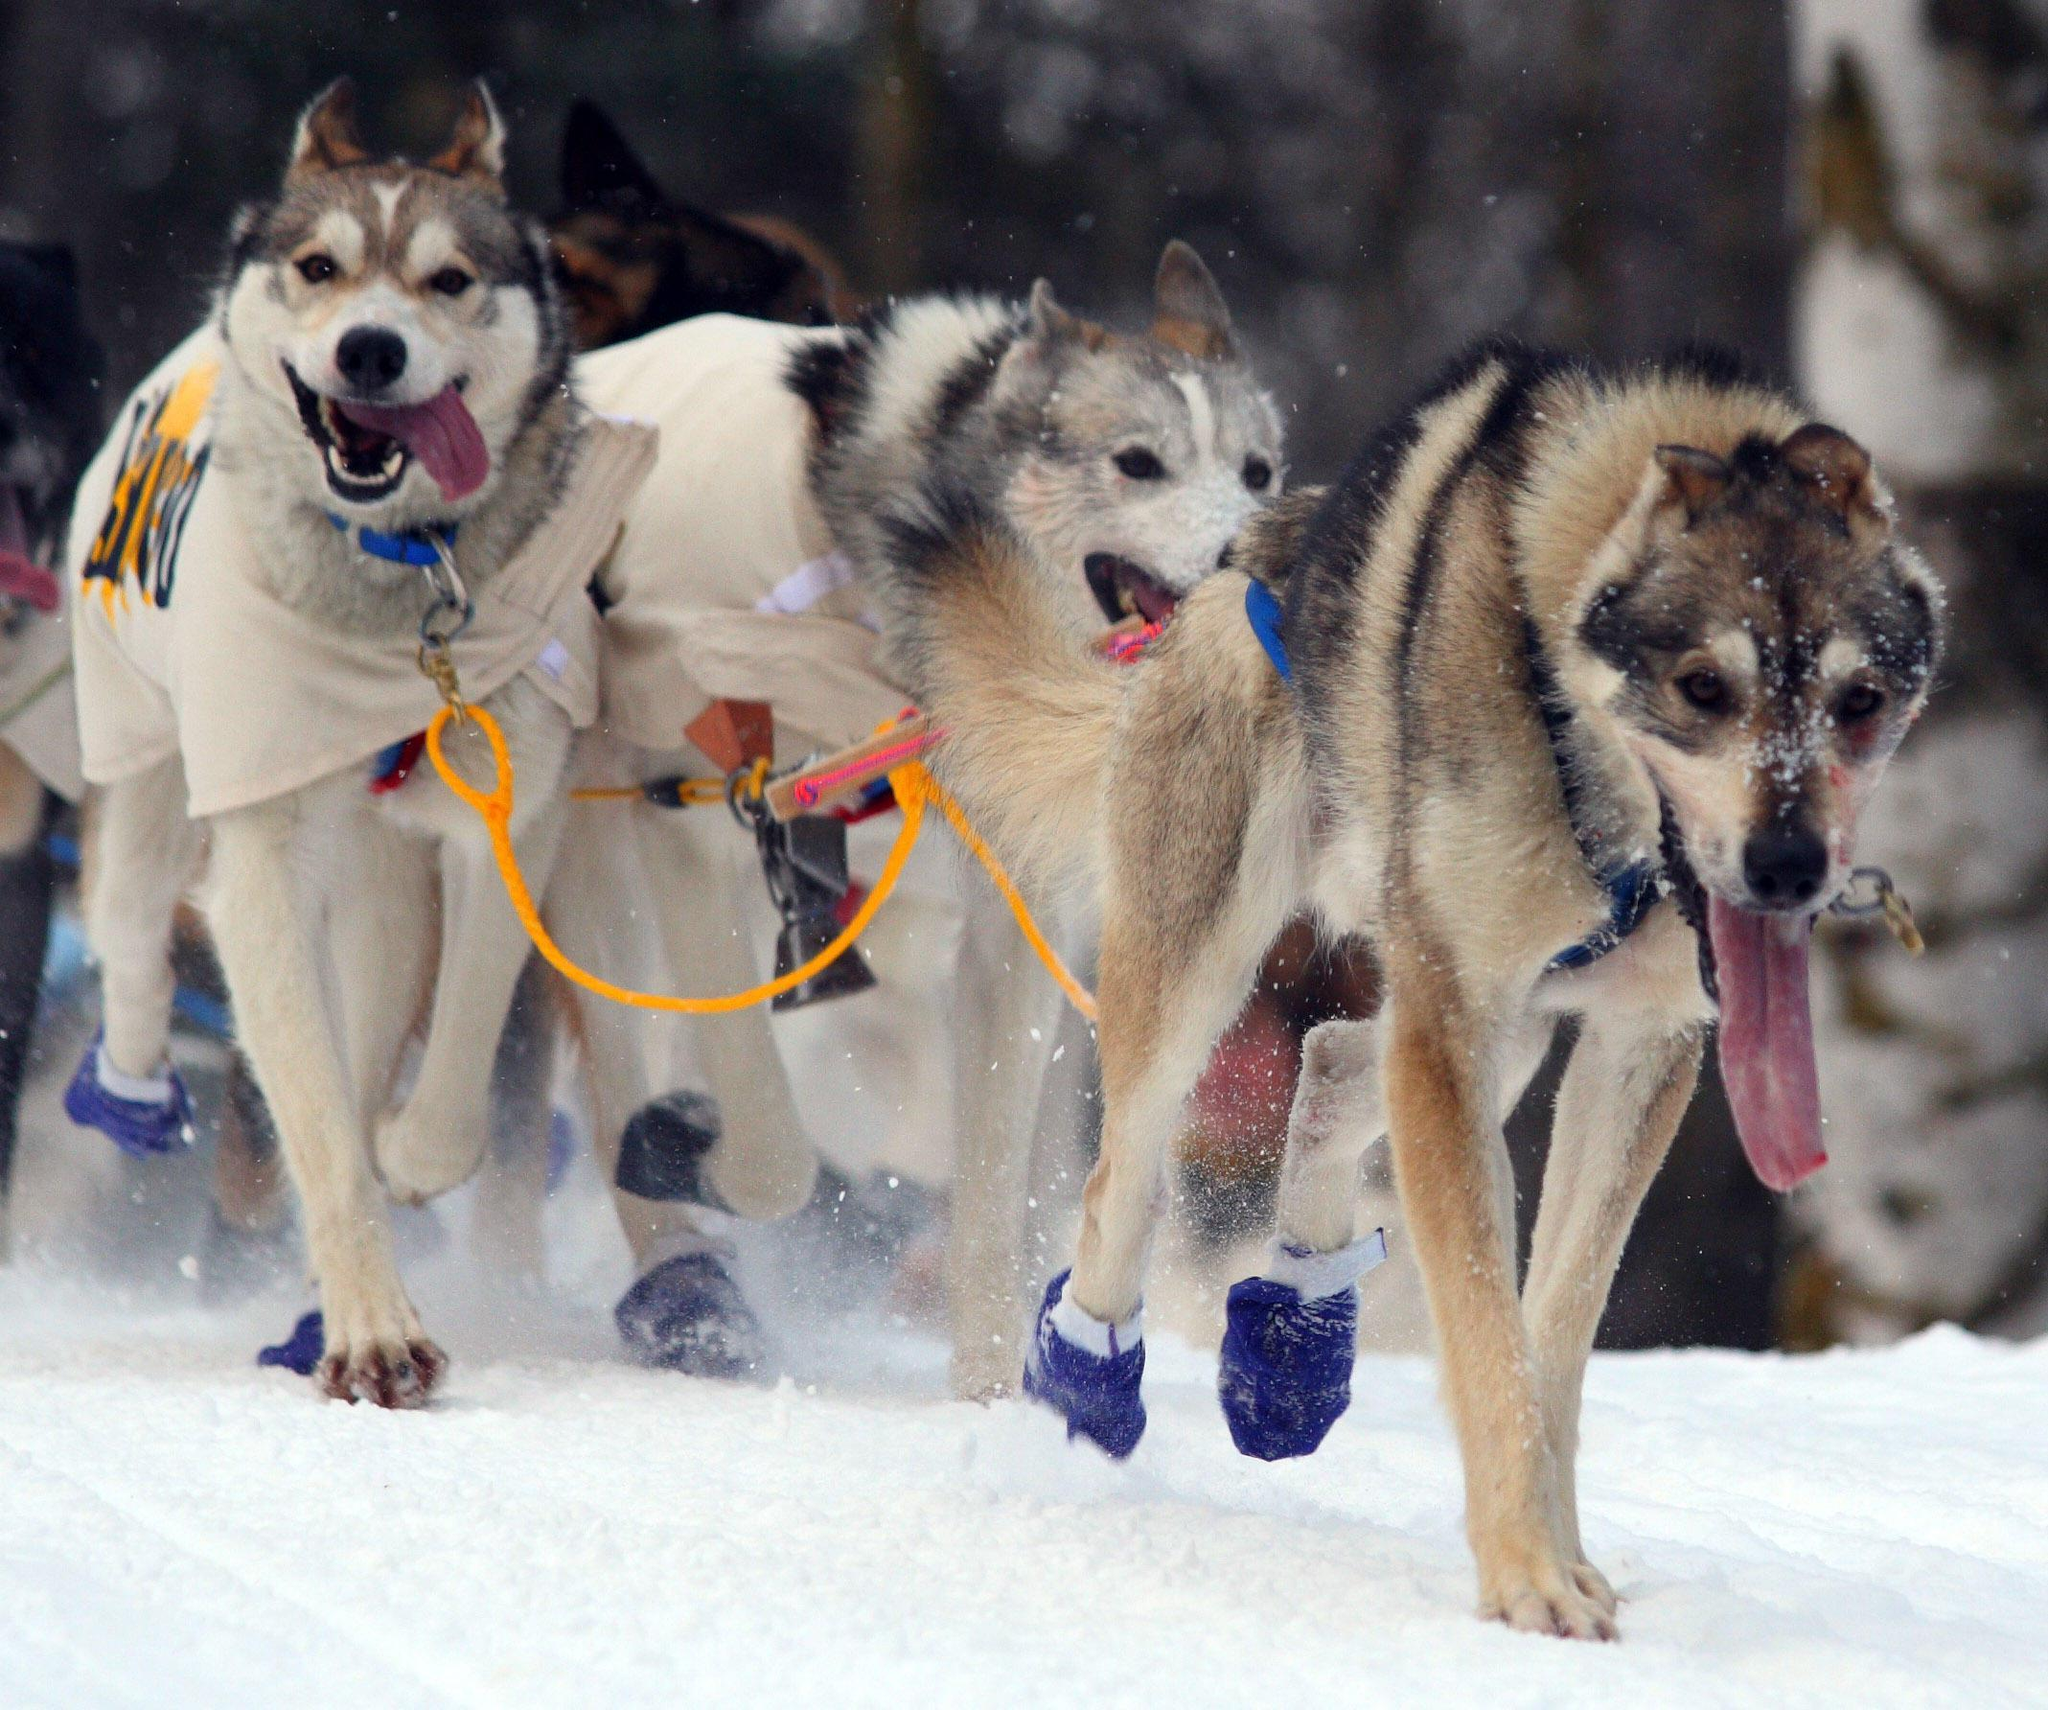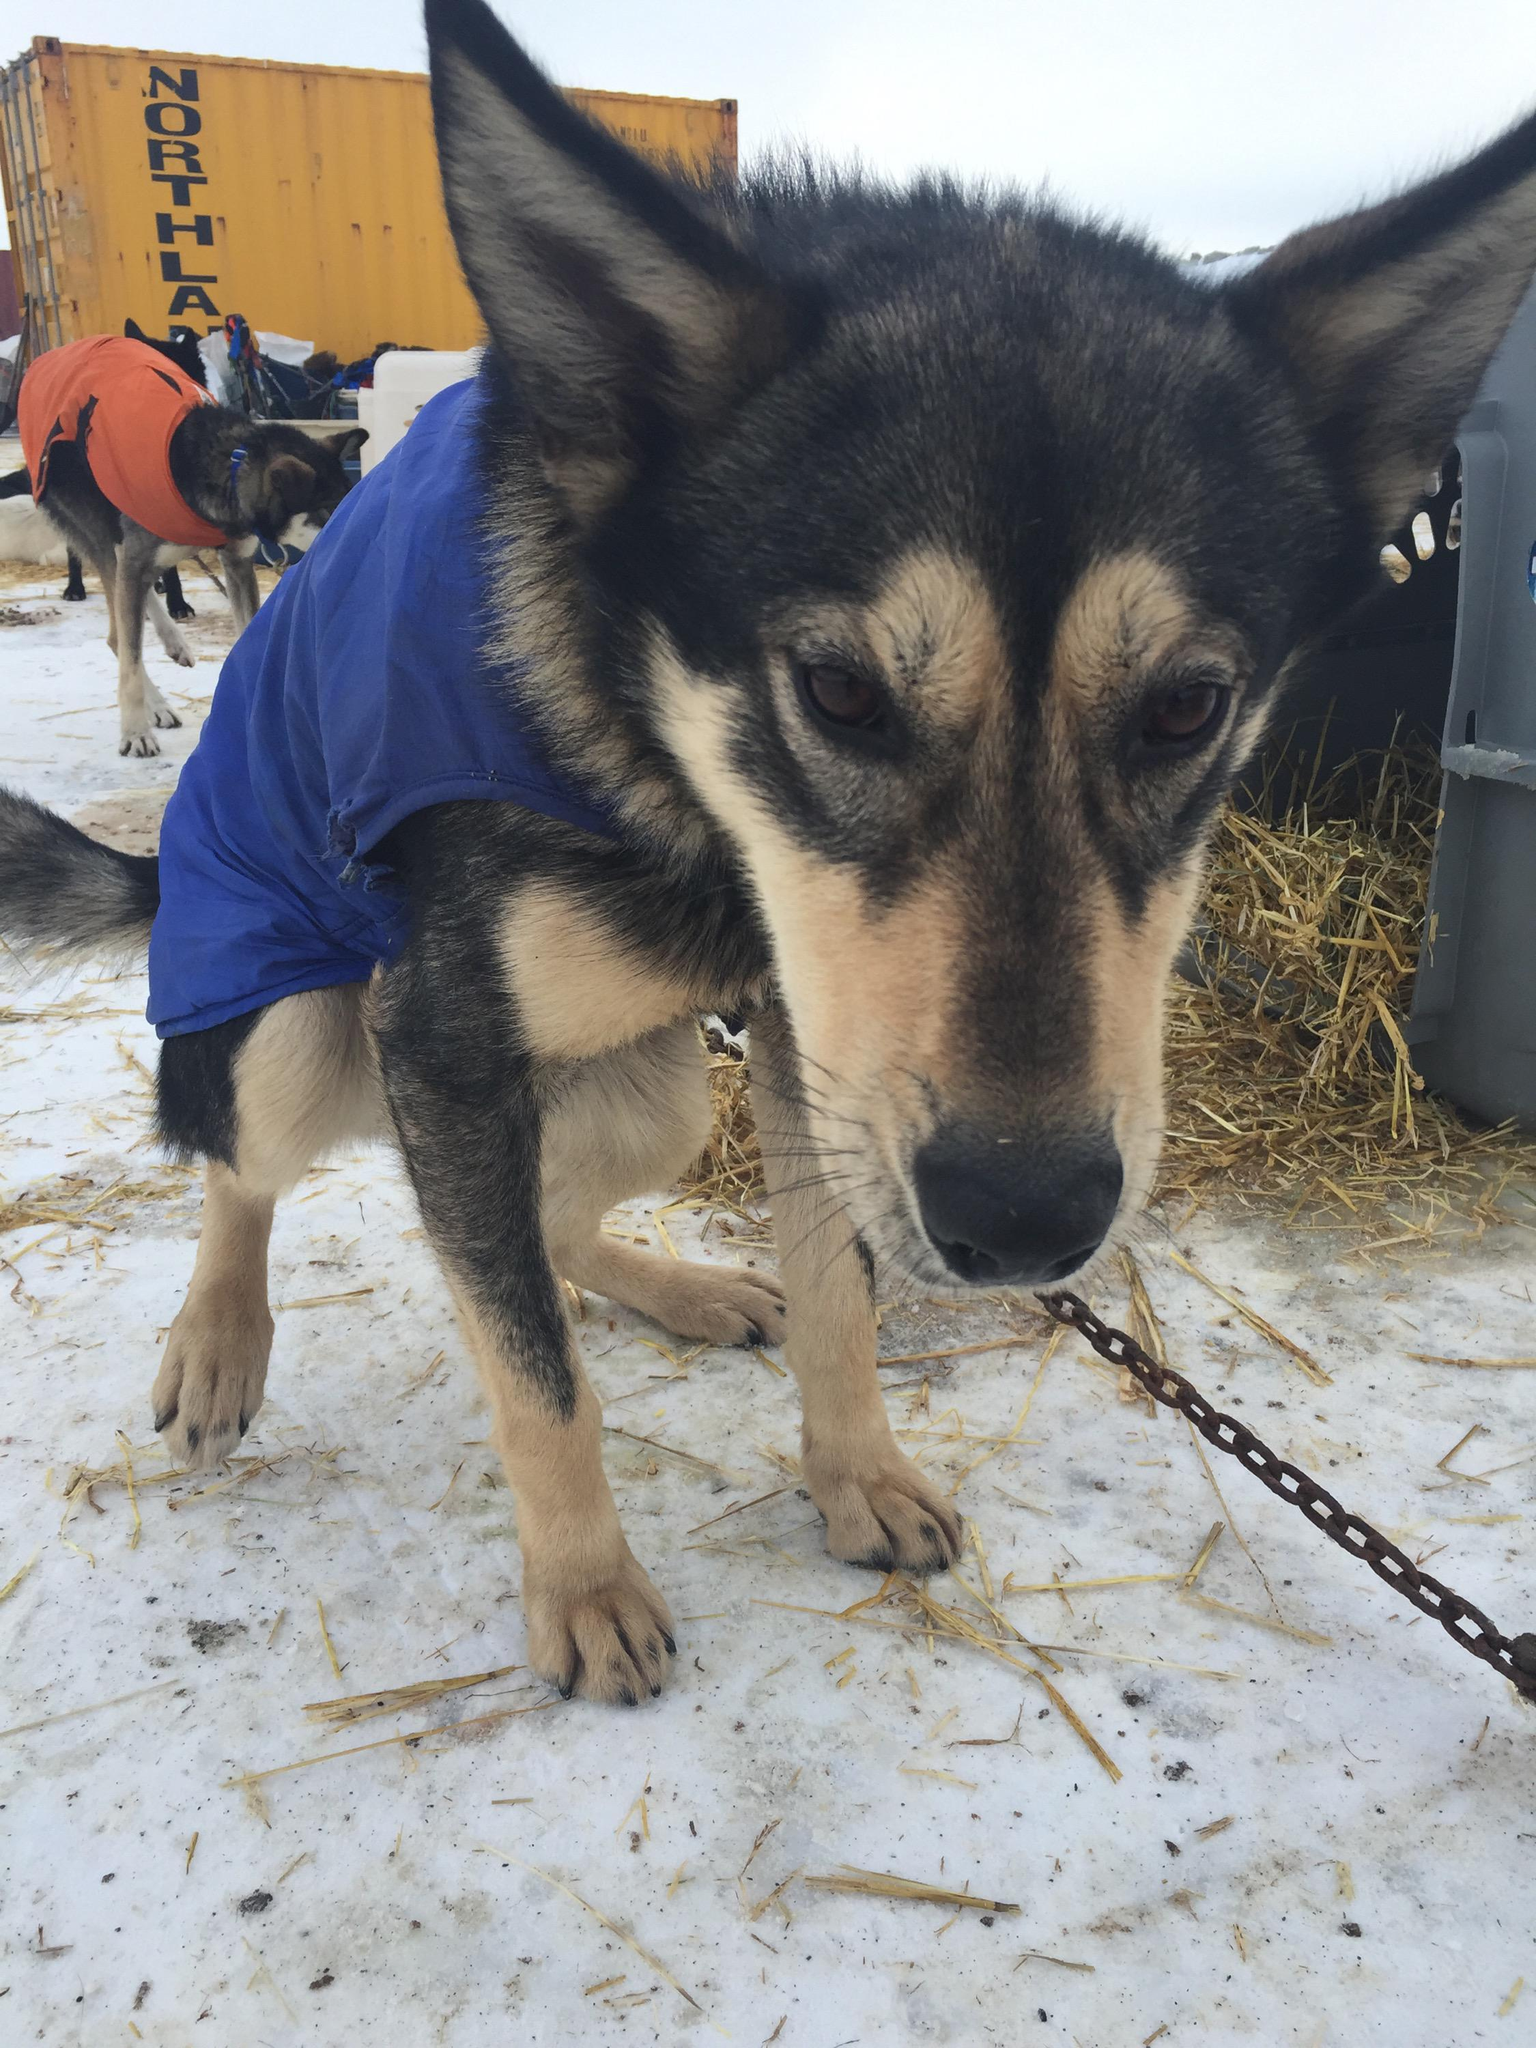The first image is the image on the left, the second image is the image on the right. Analyze the images presented: Is the assertion "A person is being pulled by a team of dogs in one image." valid? Answer yes or no. No. 